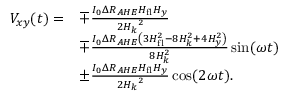<formula> <loc_0><loc_0><loc_500><loc_500>\begin{array} { r l } { V _ { x y } ( t ) = } & { \mp \frac { I _ { 0 } \Delta R _ { A H E } H _ { f l } H _ { y } } { 2 { H _ { k } } ^ { 2 } } } \\ & { \mp \frac { I _ { 0 } \Delta R _ { A H E } \left ( 3 H _ { f l } ^ { 2 } - 8 H _ { k } ^ { 2 } + 4 H _ { y } ^ { 2 } \right ) } { 8 H _ { k } ^ { 2 } } \sin ( \omega t ) } \\ & { \pm \frac { I _ { 0 } \Delta R _ { A H E } H _ { f l } H _ { y } } { 2 { H _ { k } } ^ { 2 } } \cos ( 2 \omega t ) . } \end{array}</formula> 